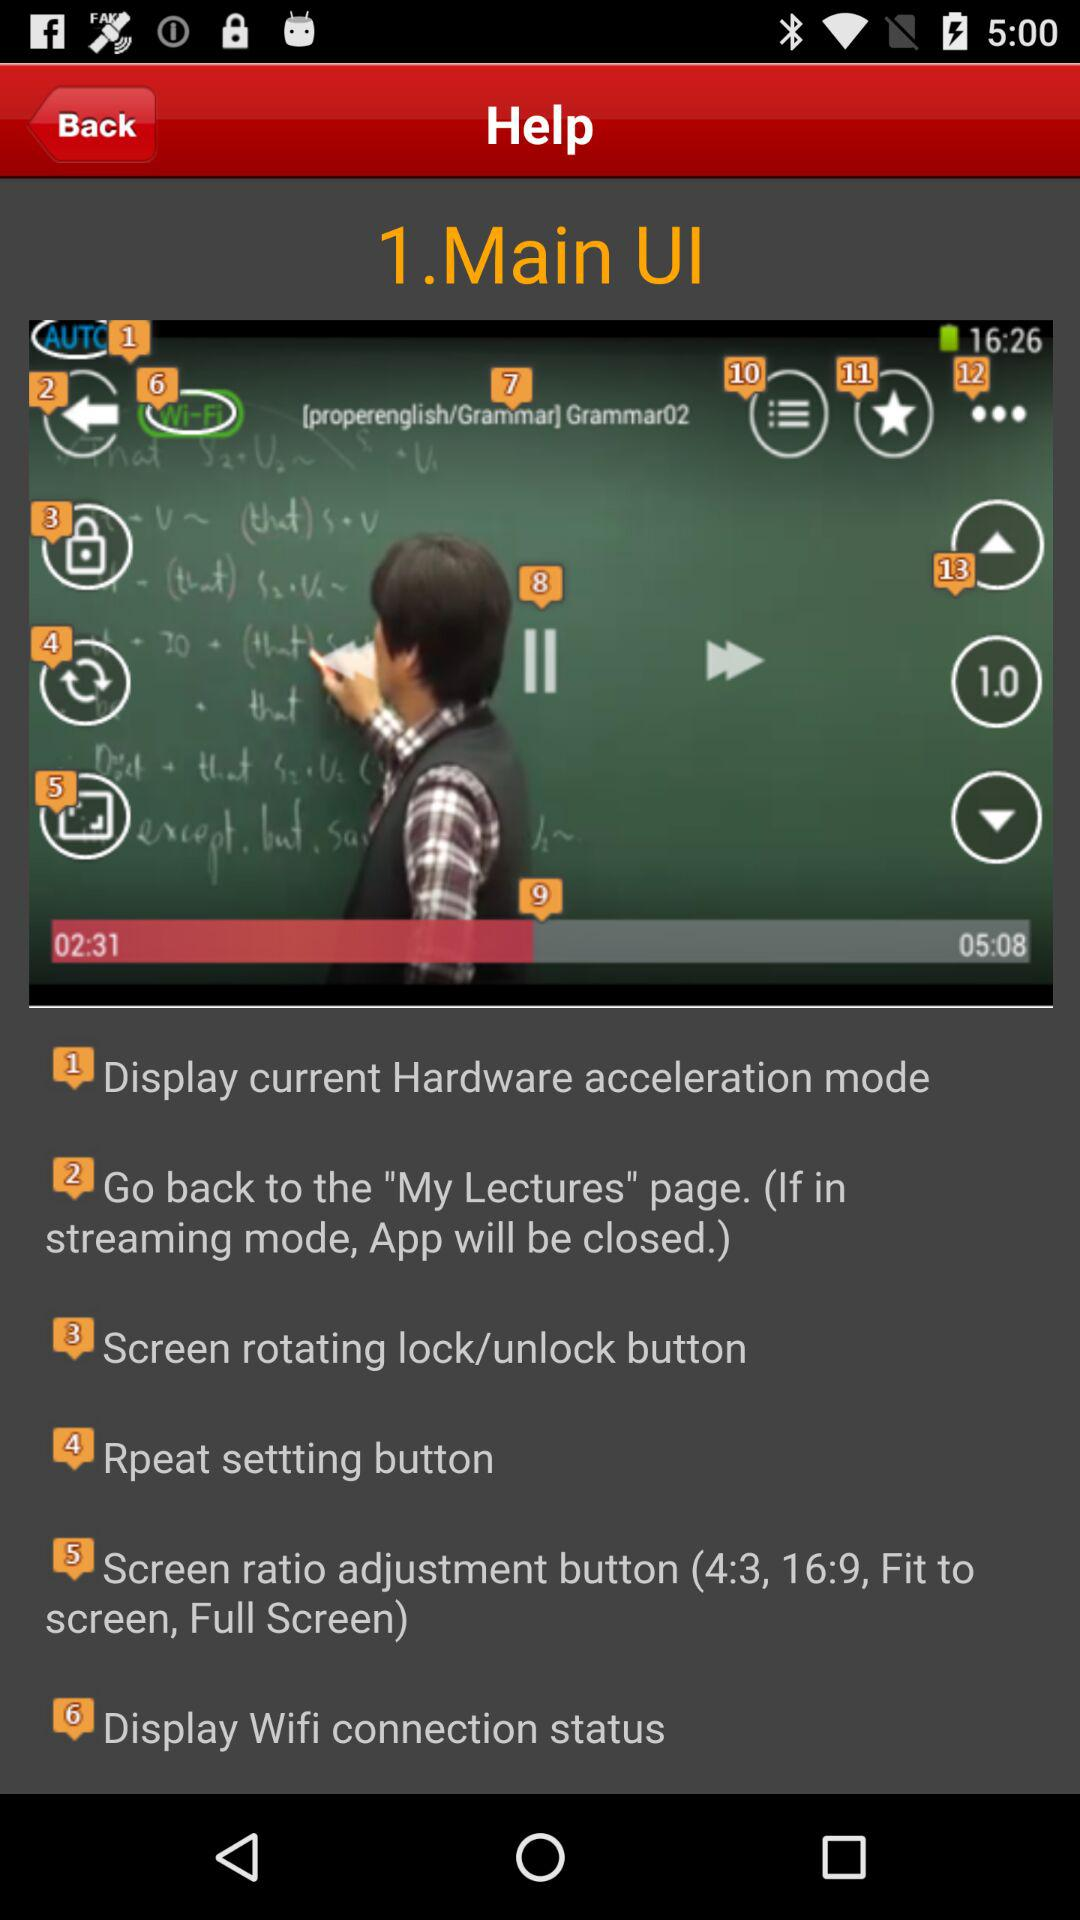What is the duration of the video? The duration of the video is 5 minutes 8 seconds. 